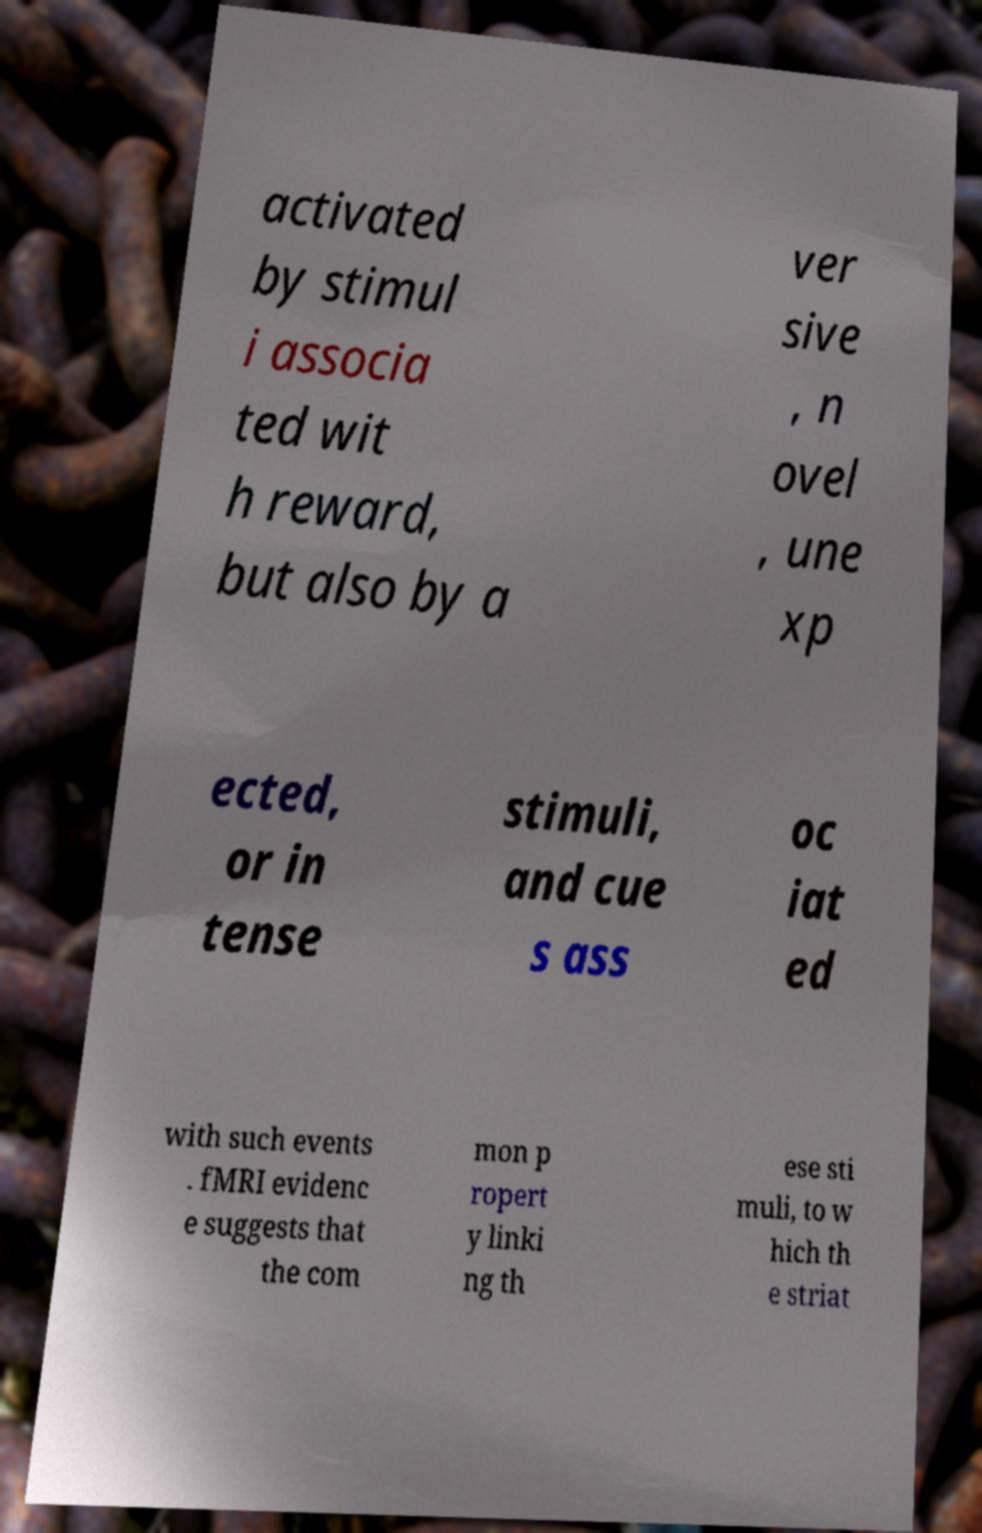Could you assist in decoding the text presented in this image and type it out clearly? activated by stimul i associa ted wit h reward, but also by a ver sive , n ovel , une xp ected, or in tense stimuli, and cue s ass oc iat ed with such events . fMRI evidenc e suggests that the com mon p ropert y linki ng th ese sti muli, to w hich th e striat 